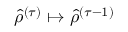Convert formula to latex. <formula><loc_0><loc_0><loc_500><loc_500>{ \hat { \rho } } ^ { ( \tau ) } \mapsto { \hat { \rho } } ^ { ( \tau - 1 ) }</formula> 